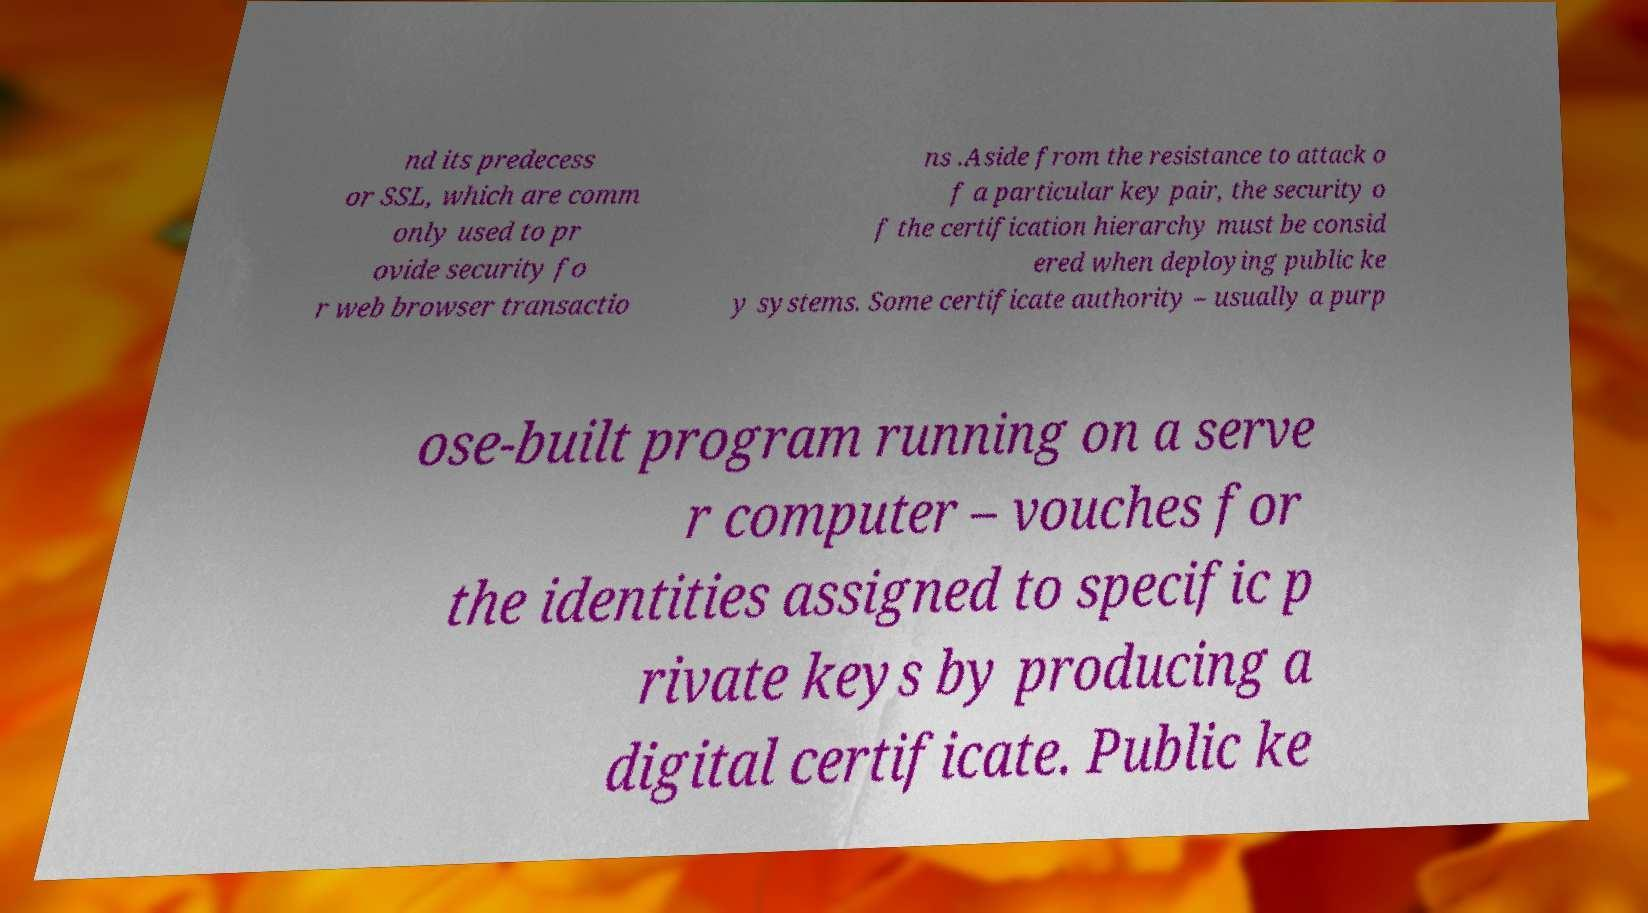Could you extract and type out the text from this image? nd its predecess or SSL, which are comm only used to pr ovide security fo r web browser transactio ns .Aside from the resistance to attack o f a particular key pair, the security o f the certification hierarchy must be consid ered when deploying public ke y systems. Some certificate authority – usually a purp ose-built program running on a serve r computer – vouches for the identities assigned to specific p rivate keys by producing a digital certificate. Public ke 